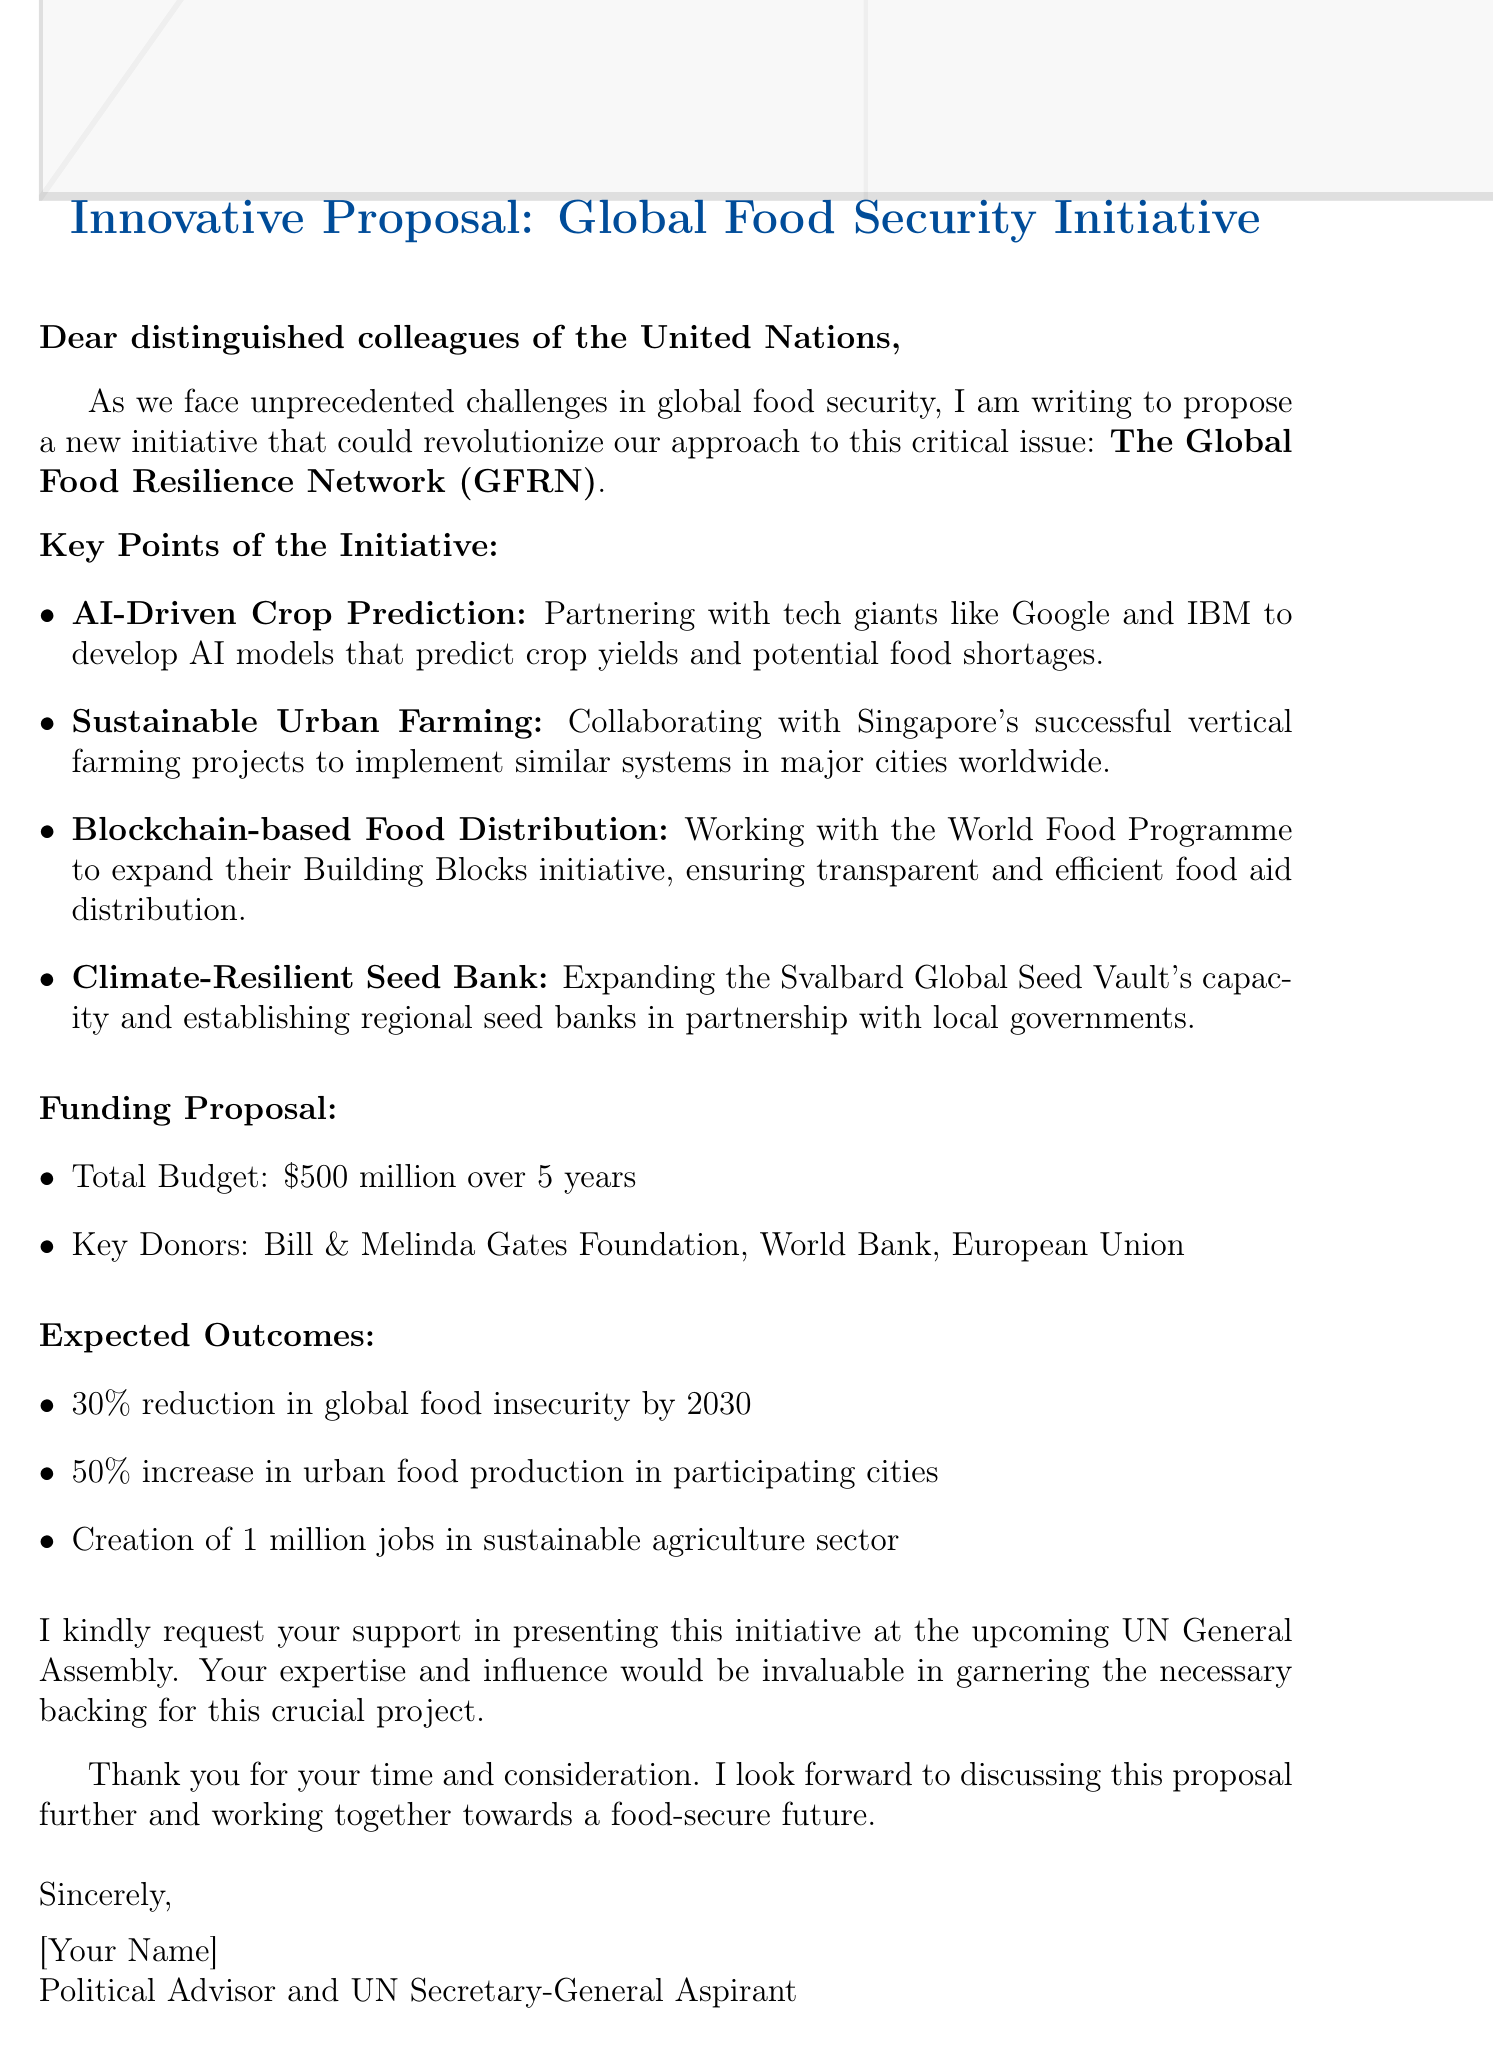what is the initiative name? The initiative name is mentioned in the introduction section of the document.
Answer: The Global Food Resilience Network (GFRN) who are the key donors? The key donors are listed under the funding proposal section of the document.
Answer: Bill & Melinda Gates Foundation, World Bank, European Union what is the total budget proposed? The total budget is specified in the funding proposal section of the document.
Answer: $500 million over 5 years what percentage increase in urban food production is expected? The expected outcome related to urban food production is mentioned in the expected outcomes section.
Answer: 50% what is the expected reduction in global food insecurity by 2030? This percentage is included in the expected outcomes section of the document.
Answer: 30% which tech giants are mentioned in the AI-Driven Crop Prediction? The document lists specific companies involved in this initiative.
Answer: Google and IBM what type of farming is proposed for collaboration with Singapore? The document refers to a specific farming method as a key point of the initiative.
Answer: Sustainable Urban Farming what is the call to action in the email? The call to action is outlined in the closing of the document, requesting support for a specific event.
Answer: Support in presenting this initiative at the upcoming UN General Assembly how many jobs are expected to be created in the sustainable agriculture sector? The expected job creation is detailed in the expected outcomes section of the document.
Answer: 1 million jobs 